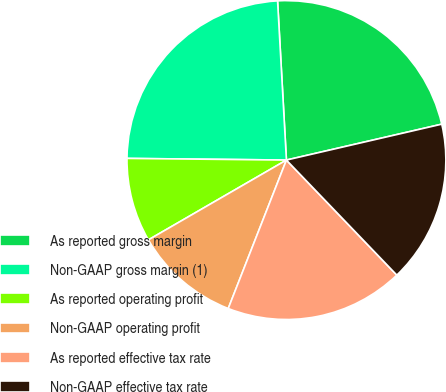Convert chart. <chart><loc_0><loc_0><loc_500><loc_500><pie_chart><fcel>As reported gross margin<fcel>Non-GAAP gross margin (1)<fcel>As reported operating profit<fcel>Non-GAAP operating profit<fcel>As reported effective tax rate<fcel>Non-GAAP effective tax rate<nl><fcel>22.27%<fcel>23.95%<fcel>8.51%<fcel>10.71%<fcel>18.12%<fcel>16.44%<nl></chart> 